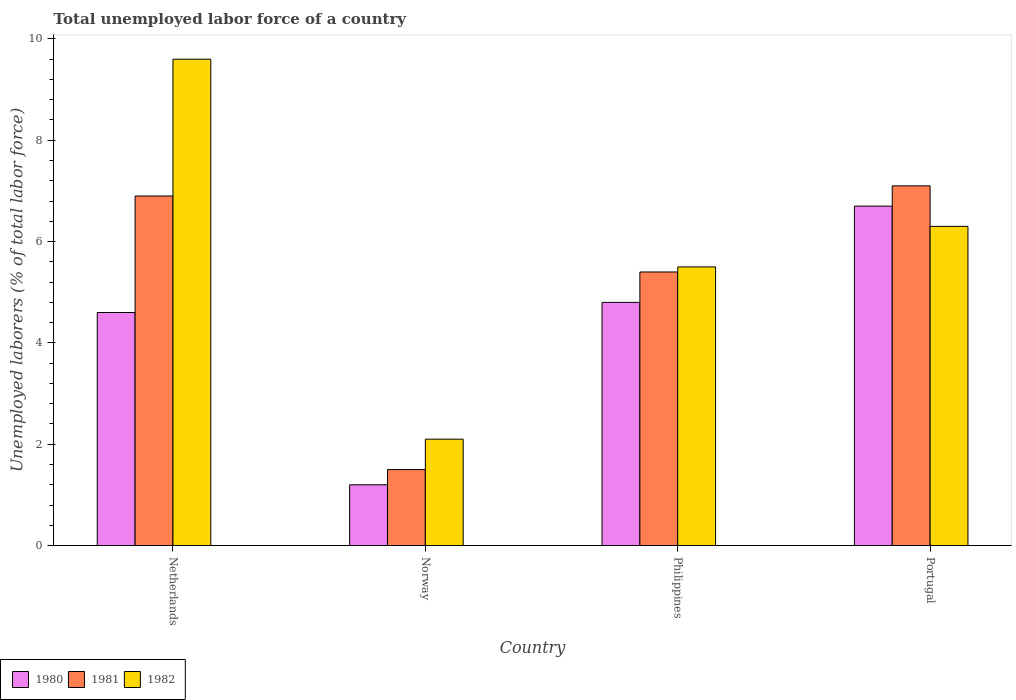How many groups of bars are there?
Make the answer very short. 4. How many bars are there on the 2nd tick from the left?
Your response must be concise. 3. How many bars are there on the 2nd tick from the right?
Provide a succinct answer. 3. What is the label of the 1st group of bars from the left?
Offer a terse response. Netherlands. What is the total unemployed labor force in 1981 in Portugal?
Ensure brevity in your answer.  7.1. Across all countries, what is the maximum total unemployed labor force in 1980?
Make the answer very short. 6.7. Across all countries, what is the minimum total unemployed labor force in 1980?
Provide a short and direct response. 1.2. In which country was the total unemployed labor force in 1980 minimum?
Make the answer very short. Norway. What is the total total unemployed labor force in 1980 in the graph?
Your answer should be very brief. 17.3. What is the difference between the total unemployed labor force in 1981 in Norway and that in Portugal?
Offer a terse response. -5.6. What is the difference between the total unemployed labor force in 1982 in Portugal and the total unemployed labor force in 1981 in Netherlands?
Your answer should be very brief. -0.6. What is the average total unemployed labor force in 1980 per country?
Provide a succinct answer. 4.32. What is the difference between the total unemployed labor force of/in 1982 and total unemployed labor force of/in 1981 in Philippines?
Your answer should be very brief. 0.1. What is the ratio of the total unemployed labor force in 1980 in Norway to that in Philippines?
Offer a very short reply. 0.25. Is the total unemployed labor force in 1982 in Philippines less than that in Portugal?
Your response must be concise. Yes. What is the difference between the highest and the second highest total unemployed labor force in 1981?
Offer a terse response. -1.5. What is the difference between the highest and the lowest total unemployed labor force in 1981?
Offer a very short reply. 5.6. Is the sum of the total unemployed labor force in 1982 in Norway and Philippines greater than the maximum total unemployed labor force in 1980 across all countries?
Keep it short and to the point. Yes. How many bars are there?
Give a very brief answer. 12. Are all the bars in the graph horizontal?
Provide a succinct answer. No. How many countries are there in the graph?
Ensure brevity in your answer.  4. What is the difference between two consecutive major ticks on the Y-axis?
Your answer should be very brief. 2. Does the graph contain any zero values?
Your answer should be very brief. No. Does the graph contain grids?
Offer a very short reply. No. Where does the legend appear in the graph?
Give a very brief answer. Bottom left. How many legend labels are there?
Your answer should be compact. 3. How are the legend labels stacked?
Keep it short and to the point. Horizontal. What is the title of the graph?
Provide a short and direct response. Total unemployed labor force of a country. Does "2006" appear as one of the legend labels in the graph?
Your response must be concise. No. What is the label or title of the Y-axis?
Ensure brevity in your answer.  Unemployed laborers (% of total labor force). What is the Unemployed laborers (% of total labor force) of 1980 in Netherlands?
Your answer should be compact. 4.6. What is the Unemployed laborers (% of total labor force) in 1981 in Netherlands?
Offer a terse response. 6.9. What is the Unemployed laborers (% of total labor force) in 1982 in Netherlands?
Keep it short and to the point. 9.6. What is the Unemployed laborers (% of total labor force) in 1980 in Norway?
Your answer should be compact. 1.2. What is the Unemployed laborers (% of total labor force) in 1982 in Norway?
Ensure brevity in your answer.  2.1. What is the Unemployed laborers (% of total labor force) of 1980 in Philippines?
Make the answer very short. 4.8. What is the Unemployed laborers (% of total labor force) in 1981 in Philippines?
Give a very brief answer. 5.4. What is the Unemployed laborers (% of total labor force) in 1980 in Portugal?
Make the answer very short. 6.7. What is the Unemployed laborers (% of total labor force) in 1981 in Portugal?
Provide a short and direct response. 7.1. What is the Unemployed laborers (% of total labor force) of 1982 in Portugal?
Ensure brevity in your answer.  6.3. Across all countries, what is the maximum Unemployed laborers (% of total labor force) in 1980?
Make the answer very short. 6.7. Across all countries, what is the maximum Unemployed laborers (% of total labor force) in 1981?
Ensure brevity in your answer.  7.1. Across all countries, what is the maximum Unemployed laborers (% of total labor force) of 1982?
Provide a succinct answer. 9.6. Across all countries, what is the minimum Unemployed laborers (% of total labor force) in 1980?
Give a very brief answer. 1.2. Across all countries, what is the minimum Unemployed laborers (% of total labor force) in 1981?
Keep it short and to the point. 1.5. Across all countries, what is the minimum Unemployed laborers (% of total labor force) of 1982?
Offer a terse response. 2.1. What is the total Unemployed laborers (% of total labor force) in 1981 in the graph?
Provide a succinct answer. 20.9. What is the difference between the Unemployed laborers (% of total labor force) in 1981 in Netherlands and that in Norway?
Offer a terse response. 5.4. What is the difference between the Unemployed laborers (% of total labor force) of 1980 in Netherlands and that in Philippines?
Offer a terse response. -0.2. What is the difference between the Unemployed laborers (% of total labor force) of 1981 in Netherlands and that in Portugal?
Provide a short and direct response. -0.2. What is the difference between the Unemployed laborers (% of total labor force) in 1982 in Norway and that in Portugal?
Offer a very short reply. -4.2. What is the difference between the Unemployed laborers (% of total labor force) of 1980 in Philippines and that in Portugal?
Your response must be concise. -1.9. What is the difference between the Unemployed laborers (% of total labor force) in 1981 in Philippines and that in Portugal?
Make the answer very short. -1.7. What is the difference between the Unemployed laborers (% of total labor force) in 1982 in Philippines and that in Portugal?
Provide a short and direct response. -0.8. What is the difference between the Unemployed laborers (% of total labor force) of 1980 in Netherlands and the Unemployed laborers (% of total labor force) of 1981 in Philippines?
Offer a very short reply. -0.8. What is the difference between the Unemployed laborers (% of total labor force) of 1980 in Netherlands and the Unemployed laborers (% of total labor force) of 1982 in Philippines?
Keep it short and to the point. -0.9. What is the difference between the Unemployed laborers (% of total labor force) of 1981 in Netherlands and the Unemployed laborers (% of total labor force) of 1982 in Portugal?
Your answer should be very brief. 0.6. What is the difference between the Unemployed laborers (% of total labor force) of 1980 in Norway and the Unemployed laborers (% of total labor force) of 1981 in Philippines?
Your answer should be compact. -4.2. What is the difference between the Unemployed laborers (% of total labor force) in 1980 in Norway and the Unemployed laborers (% of total labor force) in 1982 in Philippines?
Make the answer very short. -4.3. What is the difference between the Unemployed laborers (% of total labor force) in 1981 in Norway and the Unemployed laborers (% of total labor force) in 1982 in Philippines?
Your answer should be very brief. -4. What is the difference between the Unemployed laborers (% of total labor force) of 1980 in Norway and the Unemployed laborers (% of total labor force) of 1982 in Portugal?
Your answer should be compact. -5.1. What is the difference between the Unemployed laborers (% of total labor force) of 1981 in Norway and the Unemployed laborers (% of total labor force) of 1982 in Portugal?
Provide a succinct answer. -4.8. What is the difference between the Unemployed laborers (% of total labor force) of 1980 in Philippines and the Unemployed laborers (% of total labor force) of 1982 in Portugal?
Give a very brief answer. -1.5. What is the average Unemployed laborers (% of total labor force) of 1980 per country?
Provide a succinct answer. 4.33. What is the average Unemployed laborers (% of total labor force) in 1981 per country?
Ensure brevity in your answer.  5.22. What is the average Unemployed laborers (% of total labor force) in 1982 per country?
Make the answer very short. 5.88. What is the difference between the Unemployed laborers (% of total labor force) in 1980 and Unemployed laborers (% of total labor force) in 1982 in Norway?
Offer a terse response. -0.9. What is the difference between the Unemployed laborers (% of total labor force) in 1981 and Unemployed laborers (% of total labor force) in 1982 in Norway?
Offer a very short reply. -0.6. What is the difference between the Unemployed laborers (% of total labor force) of 1980 and Unemployed laborers (% of total labor force) of 1982 in Philippines?
Provide a short and direct response. -0.7. What is the difference between the Unemployed laborers (% of total labor force) of 1980 and Unemployed laborers (% of total labor force) of 1982 in Portugal?
Your answer should be compact. 0.4. What is the ratio of the Unemployed laborers (% of total labor force) in 1980 in Netherlands to that in Norway?
Offer a very short reply. 3.83. What is the ratio of the Unemployed laborers (% of total labor force) of 1982 in Netherlands to that in Norway?
Offer a terse response. 4.57. What is the ratio of the Unemployed laborers (% of total labor force) in 1980 in Netherlands to that in Philippines?
Your answer should be very brief. 0.96. What is the ratio of the Unemployed laborers (% of total labor force) of 1981 in Netherlands to that in Philippines?
Your answer should be very brief. 1.28. What is the ratio of the Unemployed laborers (% of total labor force) in 1982 in Netherlands to that in Philippines?
Your answer should be very brief. 1.75. What is the ratio of the Unemployed laborers (% of total labor force) of 1980 in Netherlands to that in Portugal?
Ensure brevity in your answer.  0.69. What is the ratio of the Unemployed laborers (% of total labor force) in 1981 in Netherlands to that in Portugal?
Offer a terse response. 0.97. What is the ratio of the Unemployed laborers (% of total labor force) in 1982 in Netherlands to that in Portugal?
Offer a terse response. 1.52. What is the ratio of the Unemployed laborers (% of total labor force) in 1980 in Norway to that in Philippines?
Provide a short and direct response. 0.25. What is the ratio of the Unemployed laborers (% of total labor force) in 1981 in Norway to that in Philippines?
Ensure brevity in your answer.  0.28. What is the ratio of the Unemployed laborers (% of total labor force) in 1982 in Norway to that in Philippines?
Provide a succinct answer. 0.38. What is the ratio of the Unemployed laborers (% of total labor force) in 1980 in Norway to that in Portugal?
Your answer should be compact. 0.18. What is the ratio of the Unemployed laborers (% of total labor force) of 1981 in Norway to that in Portugal?
Keep it short and to the point. 0.21. What is the ratio of the Unemployed laborers (% of total labor force) of 1980 in Philippines to that in Portugal?
Provide a succinct answer. 0.72. What is the ratio of the Unemployed laborers (% of total labor force) in 1981 in Philippines to that in Portugal?
Give a very brief answer. 0.76. What is the ratio of the Unemployed laborers (% of total labor force) in 1982 in Philippines to that in Portugal?
Ensure brevity in your answer.  0.87. What is the difference between the highest and the second highest Unemployed laborers (% of total labor force) in 1980?
Your answer should be compact. 1.9. What is the difference between the highest and the second highest Unemployed laborers (% of total labor force) of 1982?
Provide a succinct answer. 3.3. What is the difference between the highest and the lowest Unemployed laborers (% of total labor force) of 1981?
Make the answer very short. 5.6. What is the difference between the highest and the lowest Unemployed laborers (% of total labor force) in 1982?
Provide a succinct answer. 7.5. 